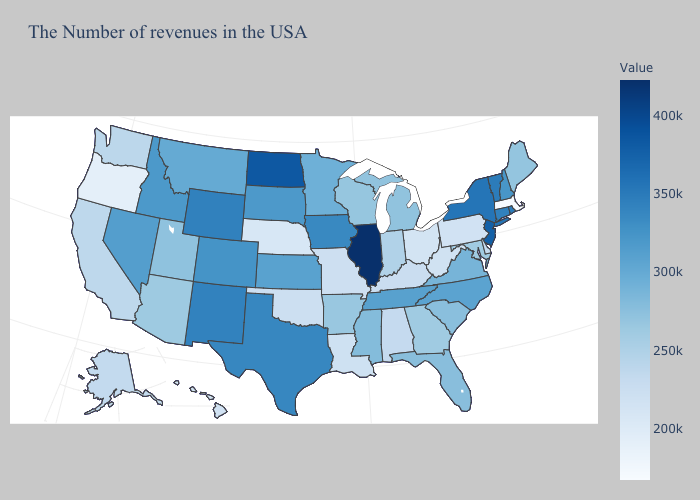Which states hav the highest value in the Northeast?
Quick response, please. New Jersey. Does Illinois have the highest value in the MidWest?
Give a very brief answer. Yes. Which states have the lowest value in the South?
Concise answer only. West Virginia. Does New Mexico have the highest value in the USA?
Give a very brief answer. No. Which states have the lowest value in the Northeast?
Give a very brief answer. Massachusetts. Does Wisconsin have the highest value in the MidWest?
Write a very short answer. No. Which states have the highest value in the USA?
Quick response, please. Illinois. 